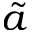<formula> <loc_0><loc_0><loc_500><loc_500>\tilde { a }</formula> 